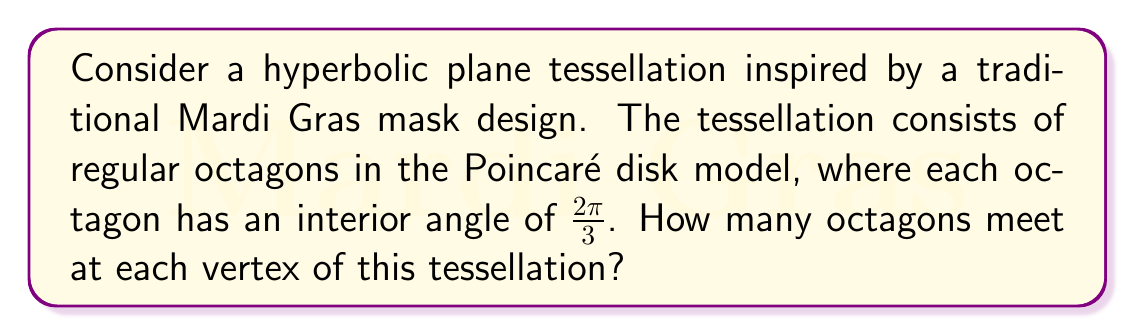Can you answer this question? Let's approach this step-by-step:

1) In hyperbolic geometry, the sum of angles in a triangle is less than $\pi$ radians (180°). This allows for tessellations that aren't possible in Euclidean geometry.

2) In the Poincaré disk model, regular polygons appear curved when drawn in Euclidean space. However, they are regular in hyperbolic space.

3) For a regular octagon in hyperbolic space:
   - It has 8 sides and 8 angles
   - Each interior angle measures $\frac{2\pi}{3}$ (given in the question)

4) At each vertex of the tessellation, several octagons meet. Let's call this number $n$.

5) For a complete rotation around a vertex (2π radians), we have:

   $$n \cdot (\pi - \frac{2\pi}{3}) = 2\pi$$

   Here, $(\pi - \frac{2\pi}{3})$ is the exterior angle of each octagon.

6) Simplifying:
   $$n \cdot \frac{\pi}{3} = 2\pi$$

7) Solving for $n$:
   $$n = \frac{2\pi}{\frac{\pi}{3}} = 6$$

Therefore, 6 octagons meet at each vertex of this hyperbolic tessellation.
Answer: 6 octagons 